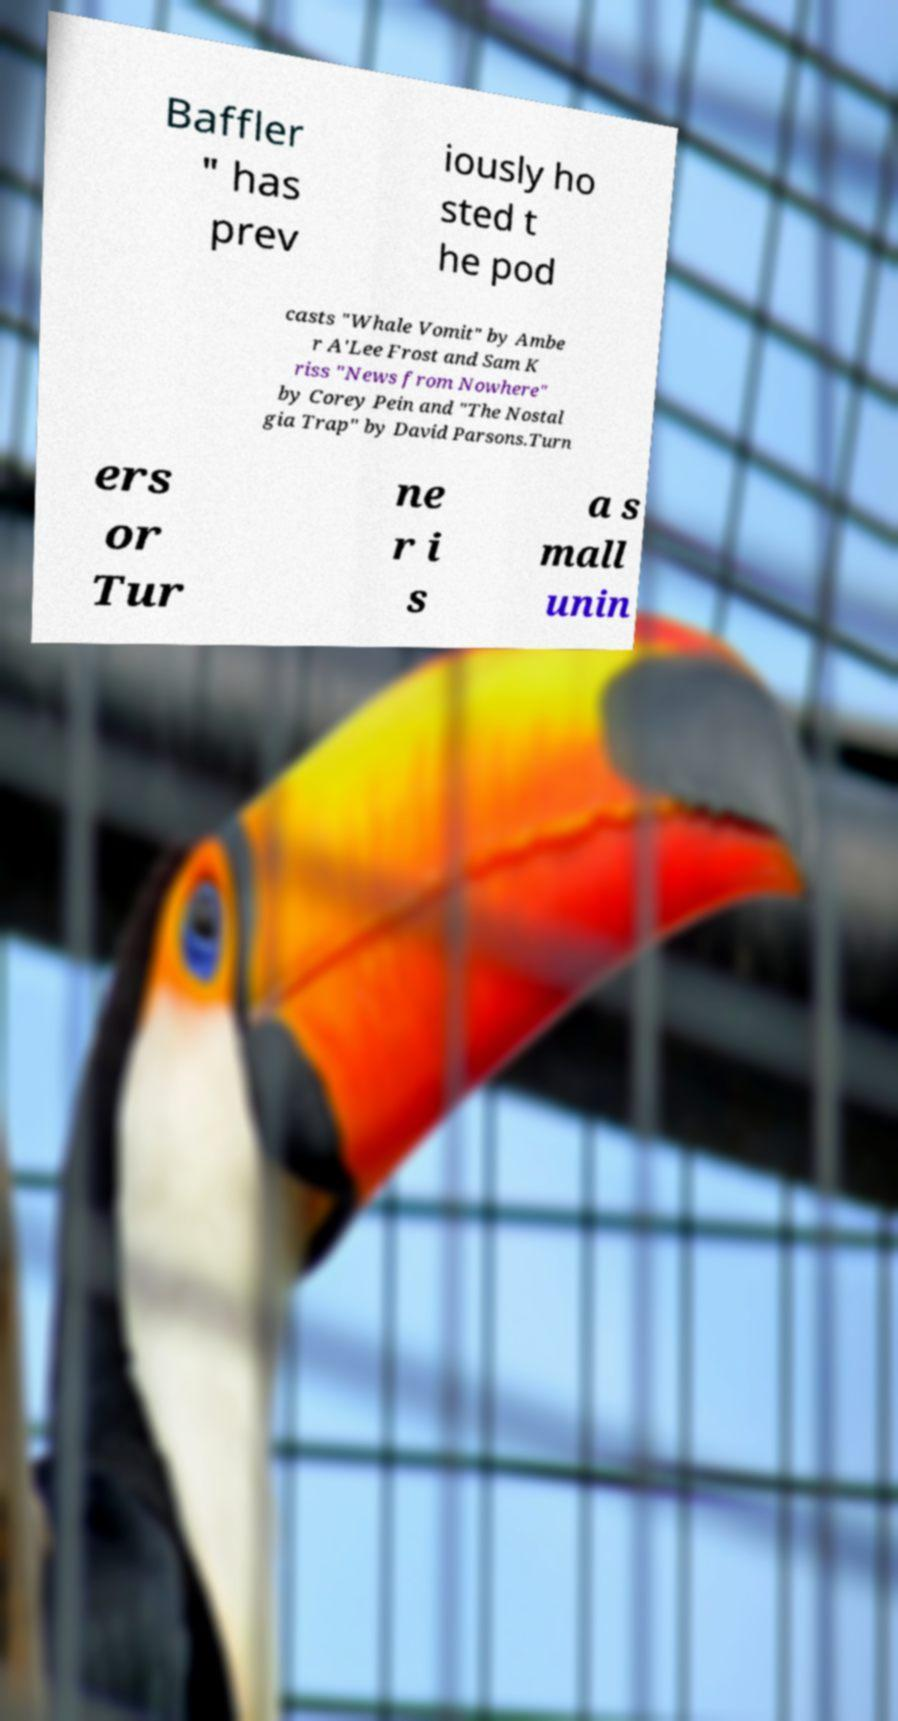I need the written content from this picture converted into text. Can you do that? Baffler " has prev iously ho sted t he pod casts "Whale Vomit" by Ambe r A'Lee Frost and Sam K riss "News from Nowhere" by Corey Pein and "The Nostal gia Trap" by David Parsons.Turn ers or Tur ne r i s a s mall unin 